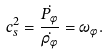Convert formula to latex. <formula><loc_0><loc_0><loc_500><loc_500>c _ { s } ^ { 2 } = \frac { \dot { P _ { \phi } } } { \dot { \rho _ { \phi } } } = \omega _ { \phi } .</formula> 